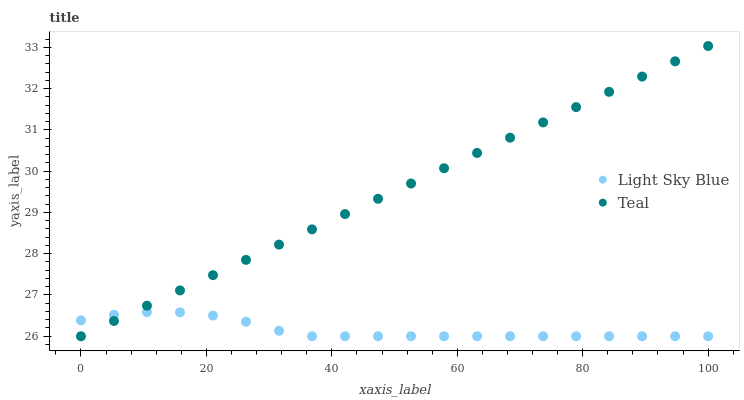Does Light Sky Blue have the minimum area under the curve?
Answer yes or no. Yes. Does Teal have the maximum area under the curve?
Answer yes or no. Yes. Does Teal have the minimum area under the curve?
Answer yes or no. No. Is Teal the smoothest?
Answer yes or no. Yes. Is Light Sky Blue the roughest?
Answer yes or no. Yes. Is Teal the roughest?
Answer yes or no. No. Does Light Sky Blue have the lowest value?
Answer yes or no. Yes. Does Teal have the highest value?
Answer yes or no. Yes. Does Light Sky Blue intersect Teal?
Answer yes or no. Yes. Is Light Sky Blue less than Teal?
Answer yes or no. No. Is Light Sky Blue greater than Teal?
Answer yes or no. No. 